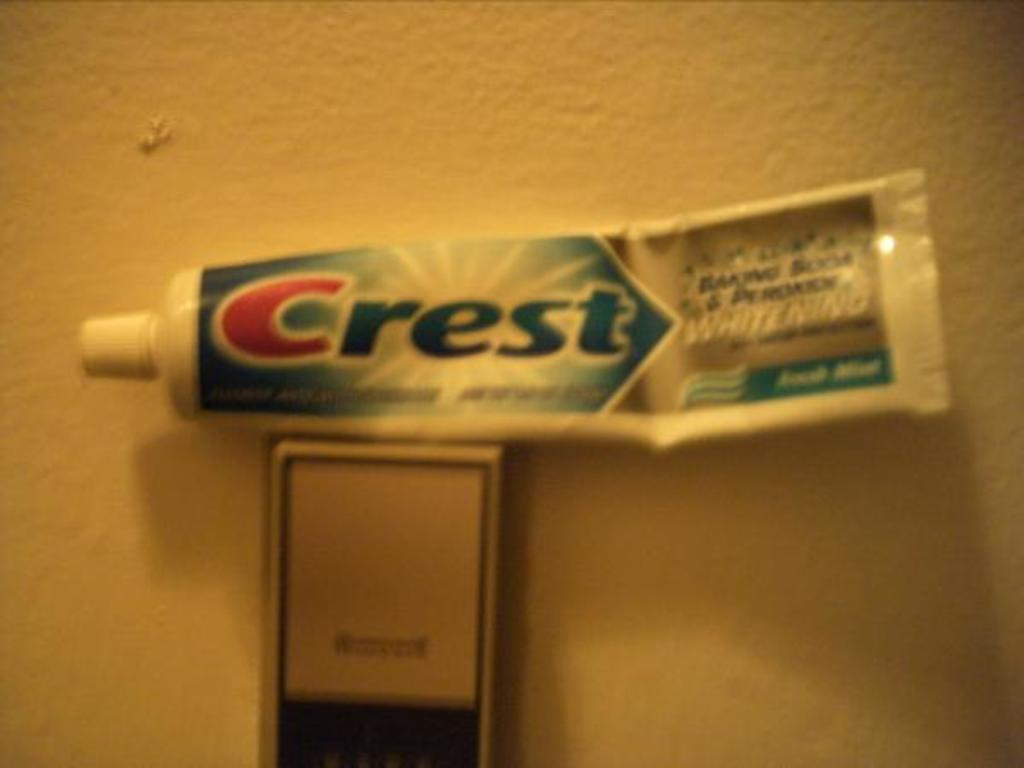<image>
Describe the image concisely. the word Crest is on the bottle on the white wall 